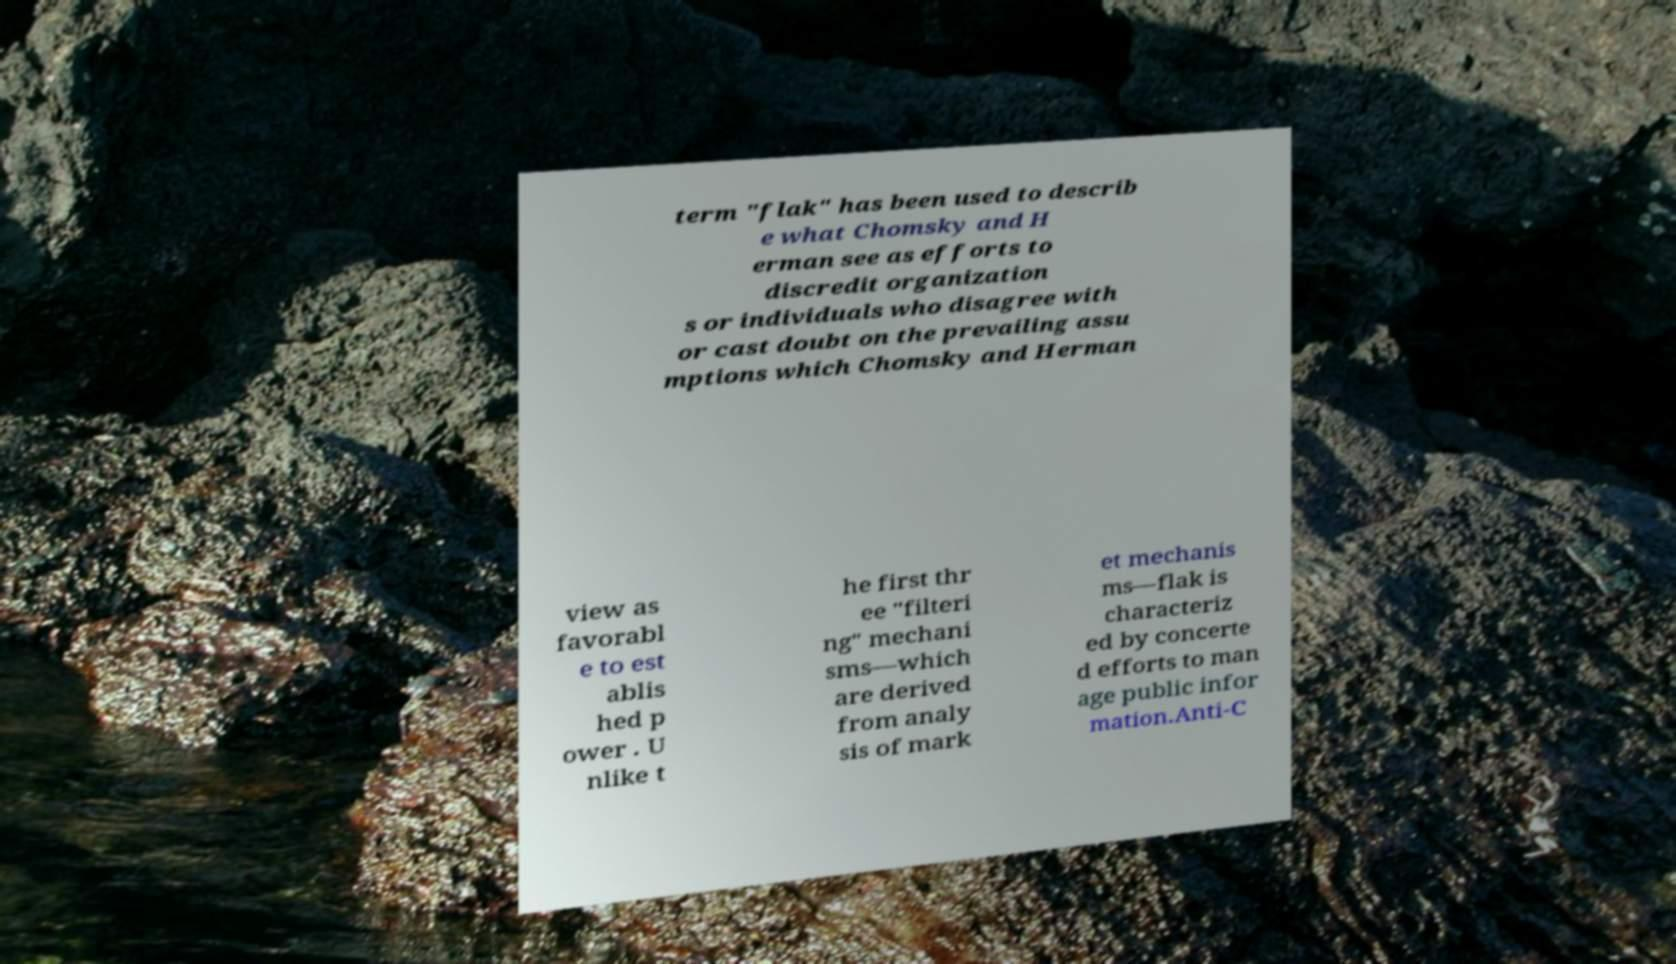Can you accurately transcribe the text from the provided image for me? term "flak" has been used to describ e what Chomsky and H erman see as efforts to discredit organization s or individuals who disagree with or cast doubt on the prevailing assu mptions which Chomsky and Herman view as favorabl e to est ablis hed p ower . U nlike t he first thr ee "filteri ng" mechani sms—which are derived from analy sis of mark et mechanis ms—flak is characteriz ed by concerte d efforts to man age public infor mation.Anti-C 